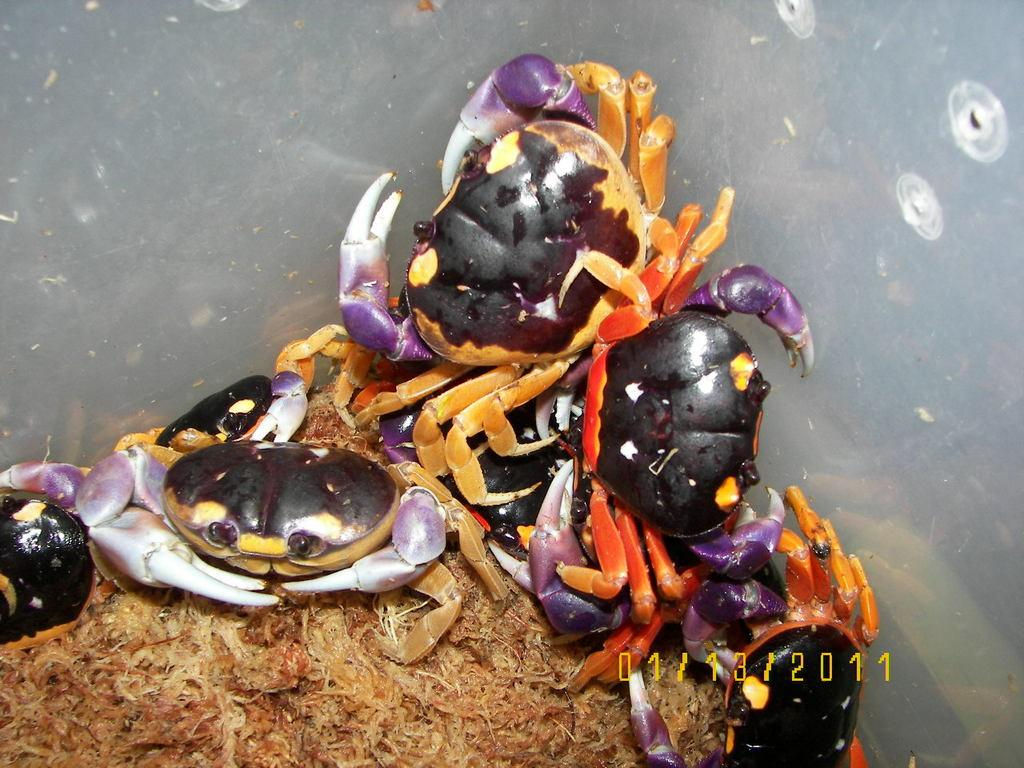What type of animals are present in the image? There are crabs in the image. Can you describe anything else that is visible near the crabs? There is an unspecified object or feature beside the crabs. What type of brake can be seen on the crabs in the image? There is no brake present on the crabs in the image. How many pages of the book are visible in the image? There is no book or page visible in the image; it only features crabs and an unspecified object or feature. 